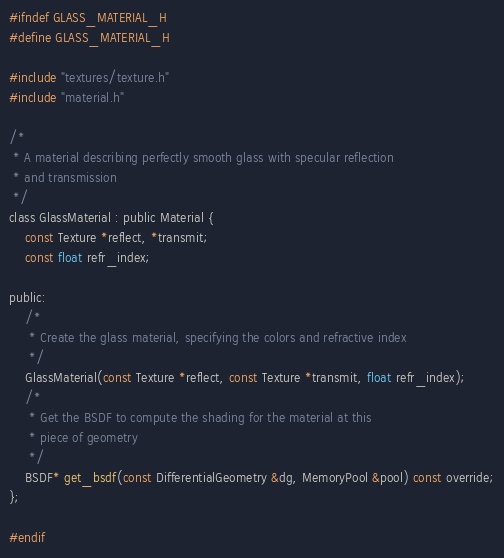<code> <loc_0><loc_0><loc_500><loc_500><_C_>#ifndef GLASS_MATERIAL_H
#define GLASS_MATERIAL_H

#include "textures/texture.h"
#include "material.h"

/*
 * A material describing perfectly smooth glass with specular reflection
 * and transmission
 */
class GlassMaterial : public Material {
	const Texture *reflect, *transmit;
	const float refr_index;

public:
	/*
	 * Create the glass material, specifying the colors and refractive index
	 */
	GlassMaterial(const Texture *reflect, const Texture *transmit, float refr_index);
	/*
	 * Get the BSDF to compute the shading for the material at this
	 * piece of geometry
	 */
	BSDF* get_bsdf(const DifferentialGeometry &dg, MemoryPool &pool) const override;
};

#endif

</code> 